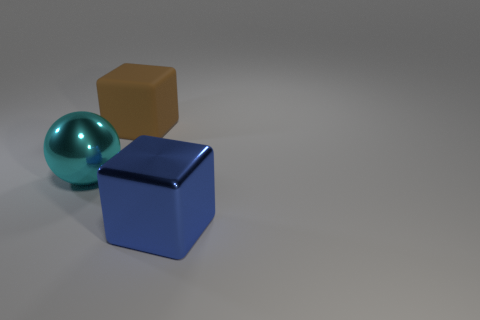Subtract all blocks. How many objects are left? 1 Subtract all blue cubes. How many cubes are left? 1 Subtract 0 red cylinders. How many objects are left? 3 Subtract 1 cubes. How many cubes are left? 1 Subtract all green balls. Subtract all purple cylinders. How many balls are left? 1 Subtract all red cylinders. How many blue cubes are left? 1 Subtract all cyan spheres. Subtract all large cyan objects. How many objects are left? 1 Add 2 big blue metal things. How many big blue metal things are left? 3 Add 1 shiny cubes. How many shiny cubes exist? 2 Add 1 purple shiny spheres. How many objects exist? 4 